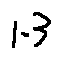Convert formula to latex. <formula><loc_0><loc_0><loc_500><loc_500>1 . 3</formula> 